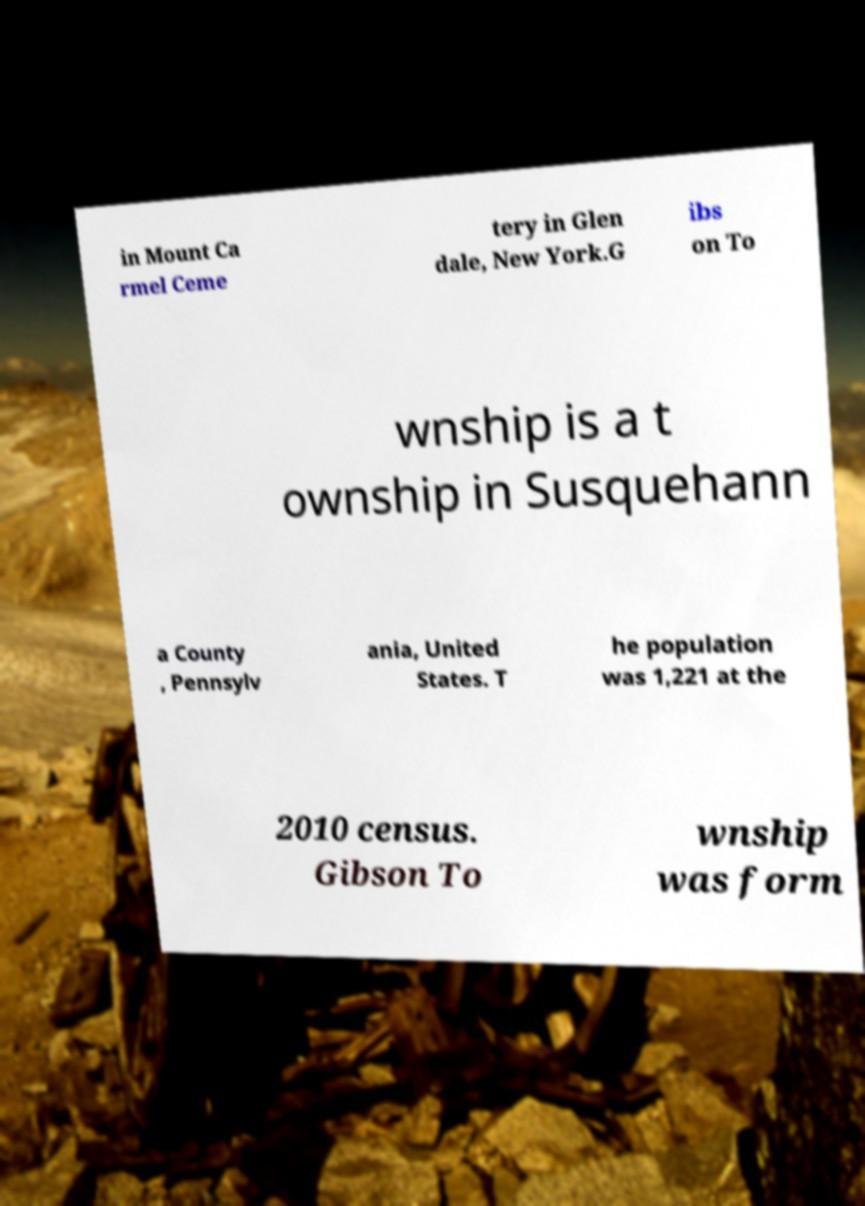What messages or text are displayed in this image? I need them in a readable, typed format. in Mount Ca rmel Ceme tery in Glen dale, New York.G ibs on To wnship is a t ownship in Susquehann a County , Pennsylv ania, United States. T he population was 1,221 at the 2010 census. Gibson To wnship was form 